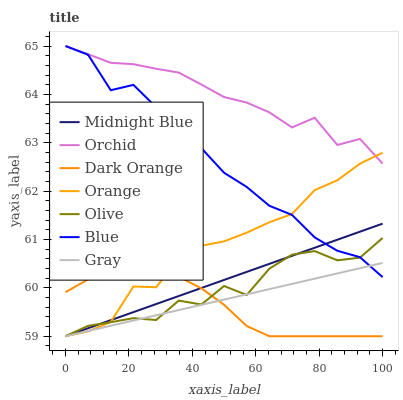Does Dark Orange have the minimum area under the curve?
Answer yes or no. Yes. Does Orchid have the maximum area under the curve?
Answer yes or no. Yes. Does Midnight Blue have the minimum area under the curve?
Answer yes or no. No. Does Midnight Blue have the maximum area under the curve?
Answer yes or no. No. Is Midnight Blue the smoothest?
Answer yes or no. Yes. Is Olive the roughest?
Answer yes or no. Yes. Is Dark Orange the smoothest?
Answer yes or no. No. Is Dark Orange the roughest?
Answer yes or no. No. Does Dark Orange have the lowest value?
Answer yes or no. Yes. Does Orchid have the lowest value?
Answer yes or no. No. Does Orchid have the highest value?
Answer yes or no. Yes. Does Midnight Blue have the highest value?
Answer yes or no. No. Is Dark Orange less than Blue?
Answer yes or no. Yes. Is Orchid greater than Olive?
Answer yes or no. Yes. Does Gray intersect Dark Orange?
Answer yes or no. Yes. Is Gray less than Dark Orange?
Answer yes or no. No. Is Gray greater than Dark Orange?
Answer yes or no. No. Does Dark Orange intersect Blue?
Answer yes or no. No. 